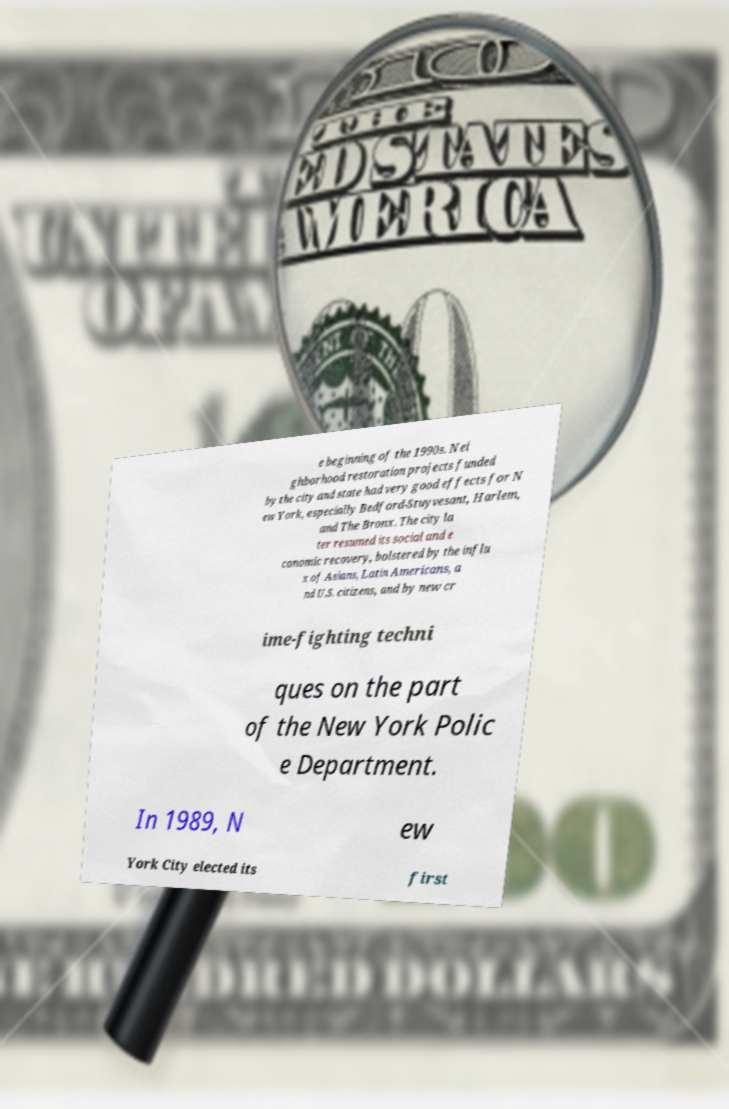For documentation purposes, I need the text within this image transcribed. Could you provide that? e beginning of the 1990s. Nei ghborhood restoration projects funded by the city and state had very good effects for N ew York, especially Bedford-Stuyvesant, Harlem, and The Bronx. The city la ter resumed its social and e conomic recovery, bolstered by the influ x of Asians, Latin Americans, a nd U.S. citizens, and by new cr ime-fighting techni ques on the part of the New York Polic e Department. In 1989, N ew York City elected its first 